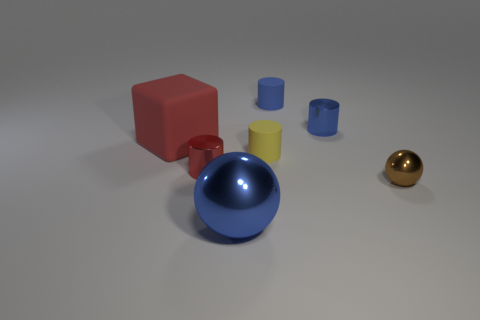Add 1 big blue metallic spheres. How many objects exist? 8 Subtract all cylinders. How many objects are left? 3 Subtract all small shiny spheres. Subtract all large matte objects. How many objects are left? 5 Add 5 small rubber things. How many small rubber things are left? 7 Add 7 small brown metal objects. How many small brown metal objects exist? 8 Subtract 1 blue balls. How many objects are left? 6 